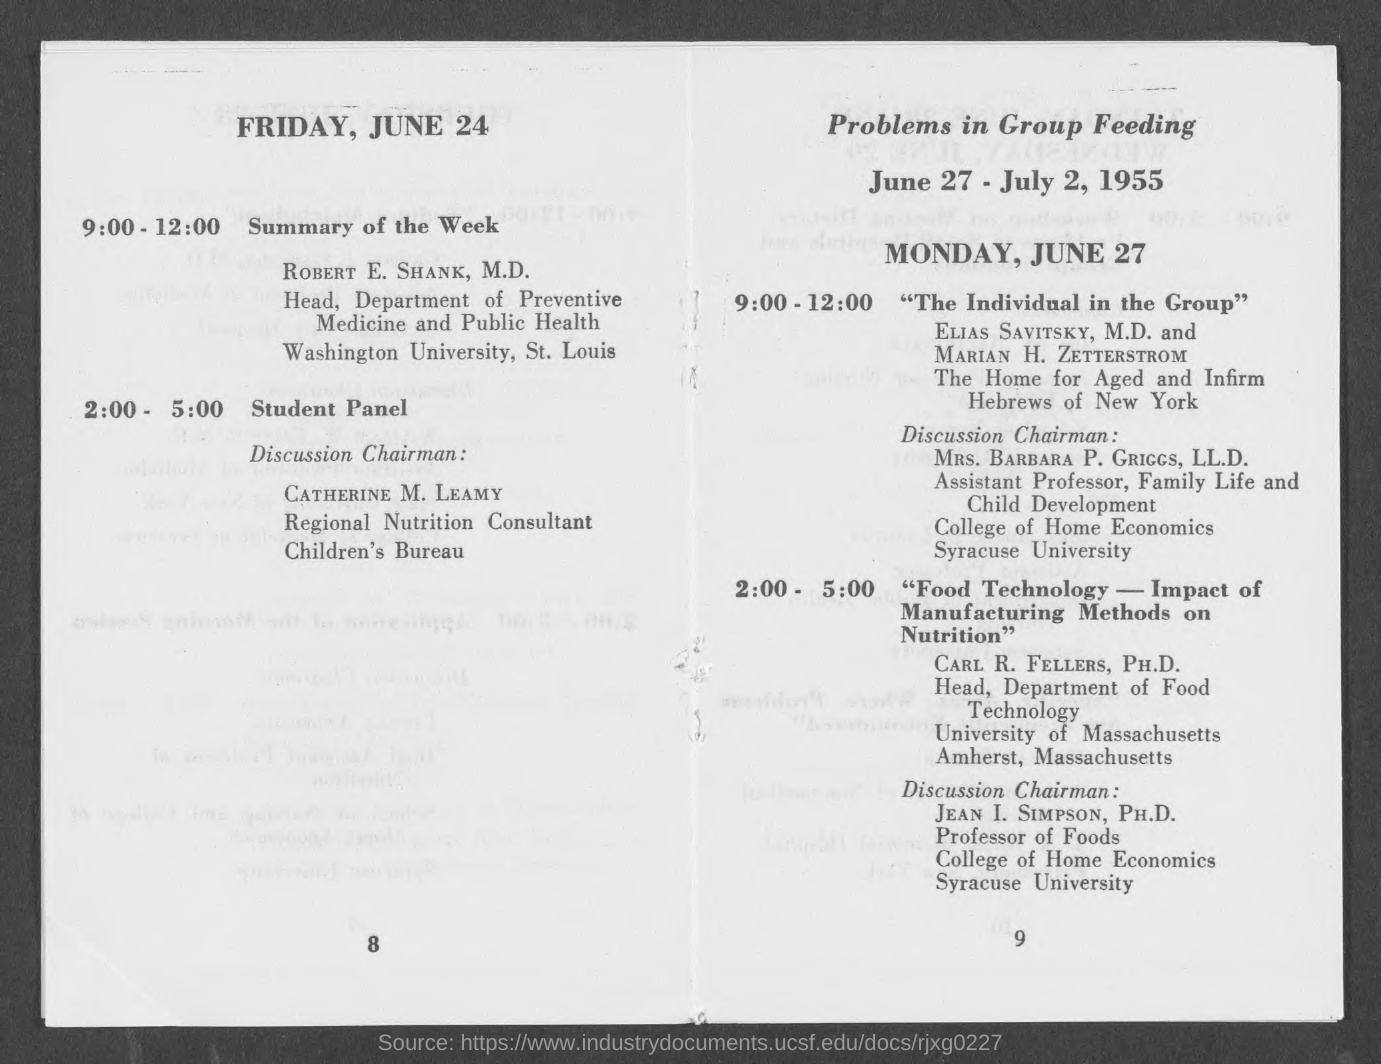When was Problems in Group Feeding discussed?
Your answer should be very brief. June 27 - July 2, 1955. 